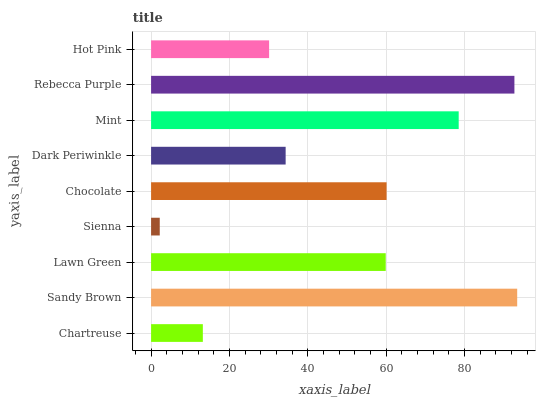Is Sienna the minimum?
Answer yes or no. Yes. Is Sandy Brown the maximum?
Answer yes or no. Yes. Is Lawn Green the minimum?
Answer yes or no. No. Is Lawn Green the maximum?
Answer yes or no. No. Is Sandy Brown greater than Lawn Green?
Answer yes or no. Yes. Is Lawn Green less than Sandy Brown?
Answer yes or no. Yes. Is Lawn Green greater than Sandy Brown?
Answer yes or no. No. Is Sandy Brown less than Lawn Green?
Answer yes or no. No. Is Lawn Green the high median?
Answer yes or no. Yes. Is Lawn Green the low median?
Answer yes or no. Yes. Is Rebecca Purple the high median?
Answer yes or no. No. Is Hot Pink the low median?
Answer yes or no. No. 